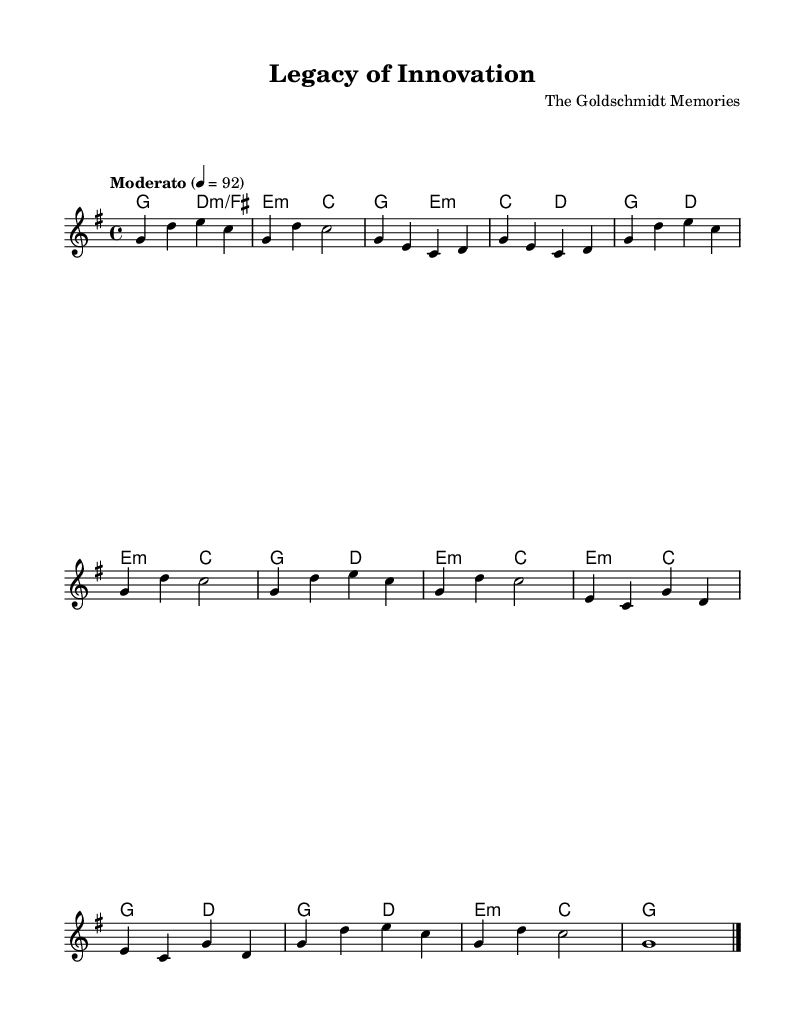What is the key signature of this music? The key signature is G major, which has one sharp (F#). This can be determined by looking at the key signature indicated at the beginning of the score.
Answer: G major What is the time signature of this music? The time signature is 4/4, which is evident from the notation found at the beginning of the score. It indicates that there are four beats in each measure and that the quarter note gets one beat.
Answer: 4/4 What is the tempo marking for this piece? The tempo marking indicates "Moderato" with a metronome marking of 92. This suggests a moderate speed for the performance. This information is found in the tempo indication at the start of the music.
Answer: Moderato, 92 How many measures are in the chorus section? The chorus section contains four measures. By examining the score, we can count the measures from the "Chorus" indication to the last chord of that section.
Answer: 4 What is the first chord of the piece? The first chord is G major. This is found at the beginning of the score within the chord section, indicating the harmony played while the melody starts.
Answer: G major What is the last note of the melody? The last note of the melody is G. This can be confirmed by looking at the last measure in the melody, where it concludes with a whole note G.
Answer: G What is the type of this song based on its characteristics? This song is classified as a power ballad. Power ballads are typically emotional and feature strong melodies, often complemented by rich harmonies and dynamic contrasts, as seen in this sheet music structure.
Answer: Power ballad 